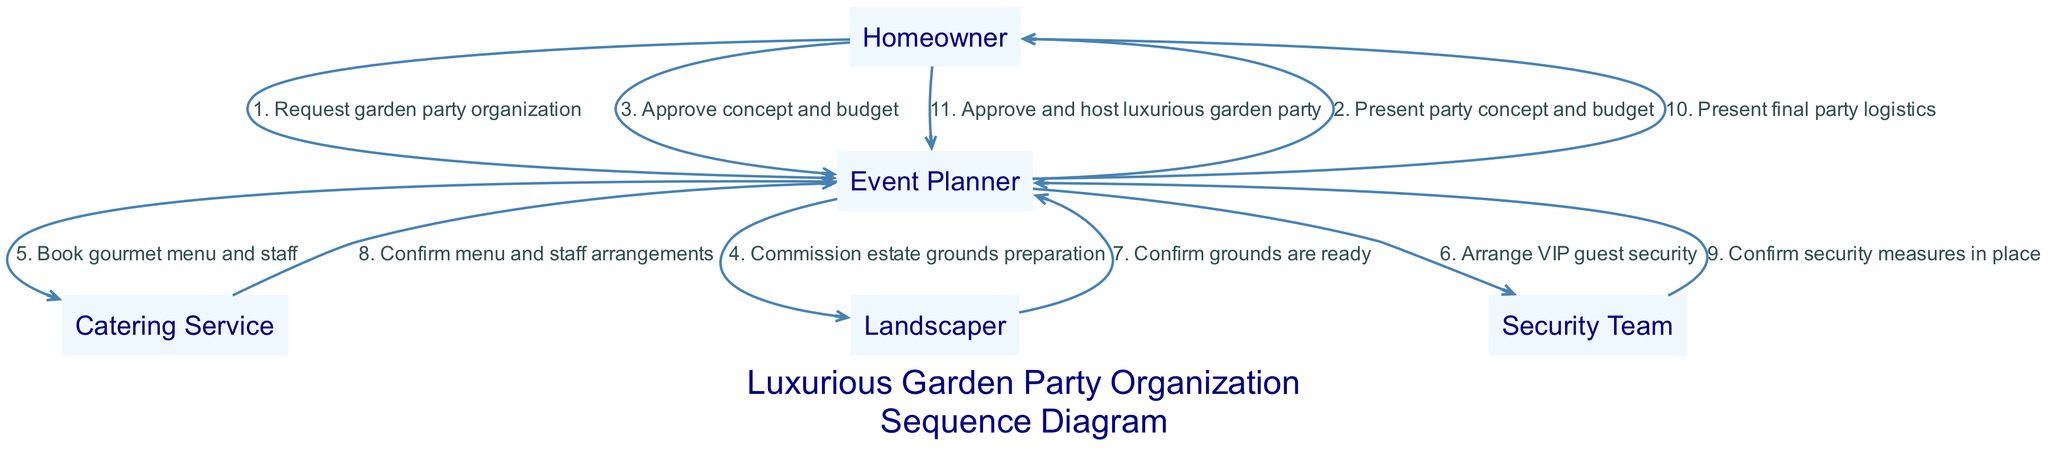What is the first action in the sequence? The first action in the sequence originates from the Homeowner who requests the organization of a garden party from the Event Planner.
Answer: Request garden party organization How many actors are involved in this diagram? The diagram features five actors which include the Homeowner, Event Planner, Catering Service, Landscaper, and Security Team.
Answer: Five What does the Event Planner do after presenting the concept? After presenting the party concept and budget to the Homeowner, the Event Planner awaits approval before proceeding with further arrangements.
Answer: Await approval Which actor is responsible for preparing the estate grounds? The Landscaper is specifically commissioned by the Event Planner to prepare the estate grounds for the upcoming garden party.
Answer: Landscaper What immediate confirmation does the Event Planner receive from the Security Team? The Security Team confirms that all security measures are in place for the garden party, providing reassurance before the event proceeds.
Answer: Confirm security measures in place What is the sequence order of final approvals before the party? The sequence order is: The Event Planner presents final party logistics, followed by the Homeowner approving these arrangements, leading to the hosting of the garden party.
Answer: Present final party logistics, approve and host Who does the Event Planner communicate with to book the catering service? The Event Planner communicates directly with the Catering Service to secure the gourmet menu and staff for the party.
Answer: Catering Service How many confirmations are made before the homeowner approves the logistics? Three confirmations are made: from the Landscaper regarding ground readiness, from the Catering Service about menu and staff, and from the Security Team about security measures.
Answer: Three confirmations 